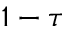Convert formula to latex. <formula><loc_0><loc_0><loc_500><loc_500>1 - \tau</formula> 